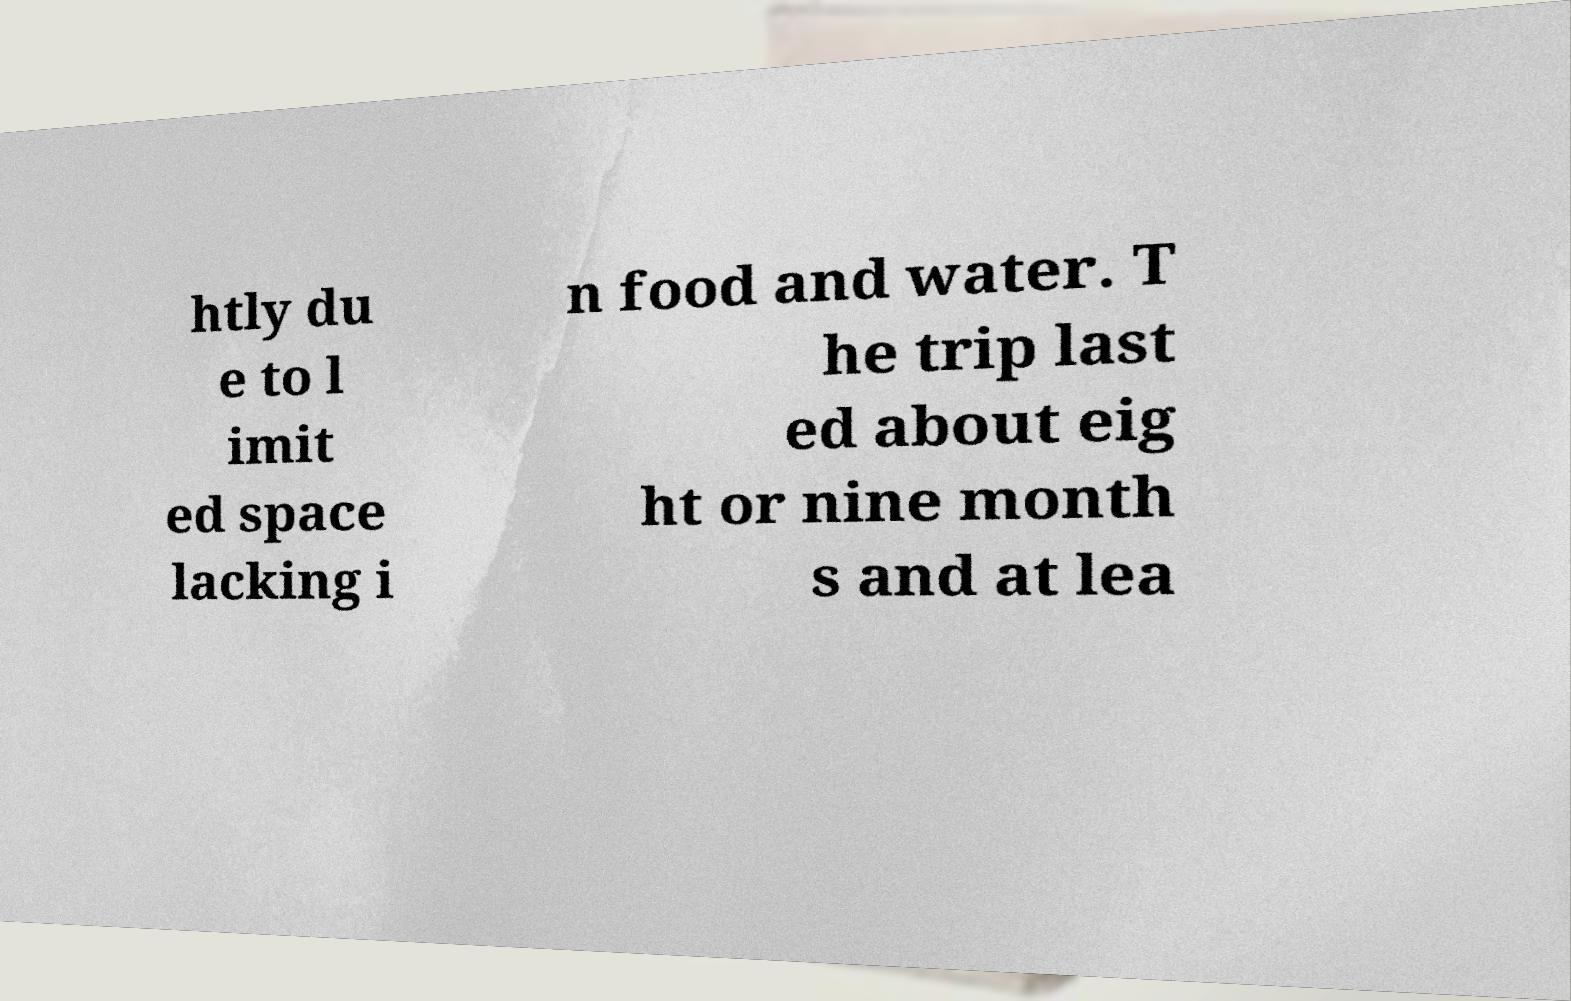There's text embedded in this image that I need extracted. Can you transcribe it verbatim? htly du e to l imit ed space lacking i n food and water. T he trip last ed about eig ht or nine month s and at lea 